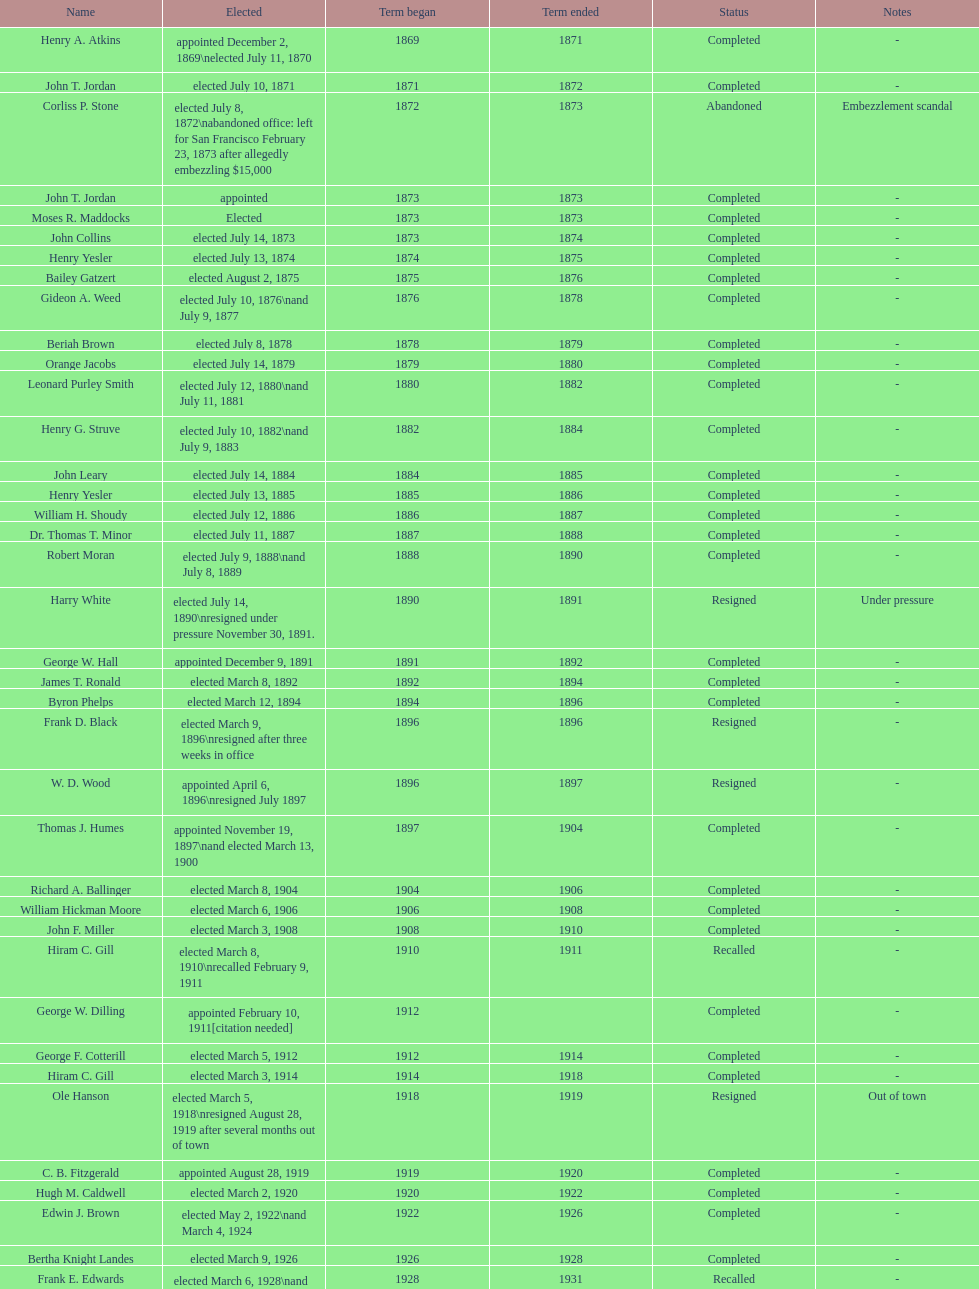Did charles royer hold office longer than paul schell? Yes. 